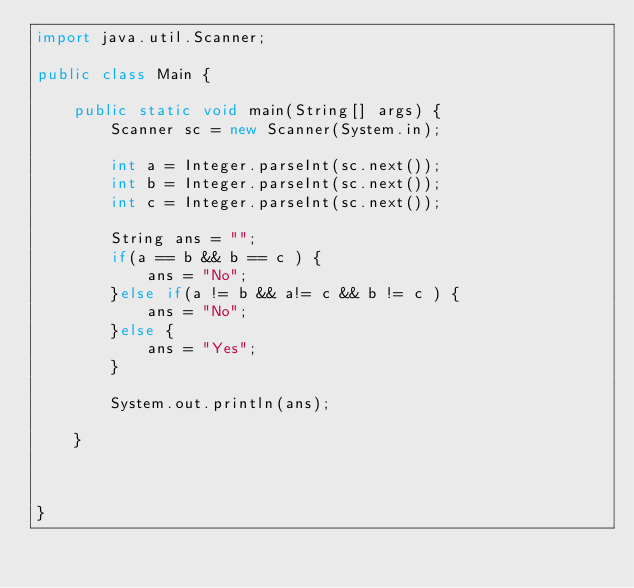<code> <loc_0><loc_0><loc_500><loc_500><_Java_>import java.util.Scanner;

public class Main {

	public static void main(String[] args) {
		Scanner sc = new Scanner(System.in);

		int a = Integer.parseInt(sc.next());
		int b = Integer.parseInt(sc.next());
		int c = Integer.parseInt(sc.next());
		
		String ans = "";
		if(a == b && b == c ) {
			ans = "No";
		}else if(a != b && a!= c && b != c ) {
			ans = "No";
		}else {
			ans = "Yes";
		}
		
		System.out.println(ans);

	}



}</code> 